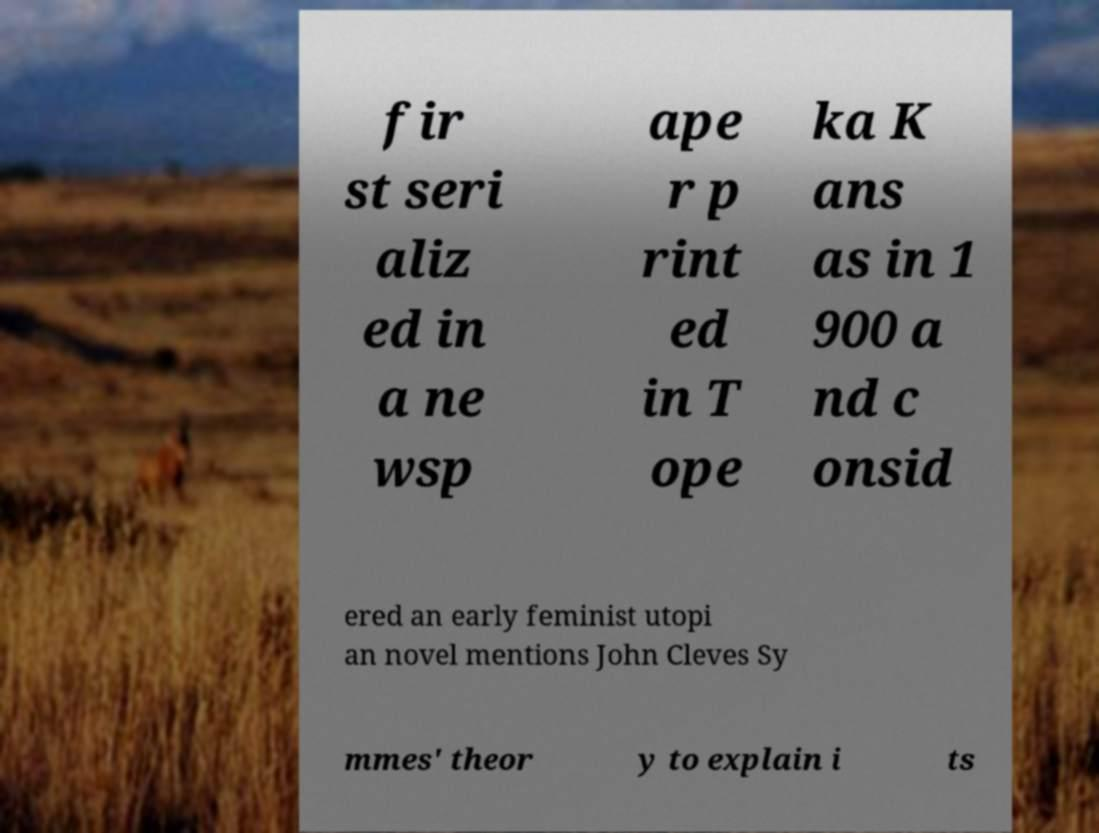There's text embedded in this image that I need extracted. Can you transcribe it verbatim? fir st seri aliz ed in a ne wsp ape r p rint ed in T ope ka K ans as in 1 900 a nd c onsid ered an early feminist utopi an novel mentions John Cleves Sy mmes' theor y to explain i ts 